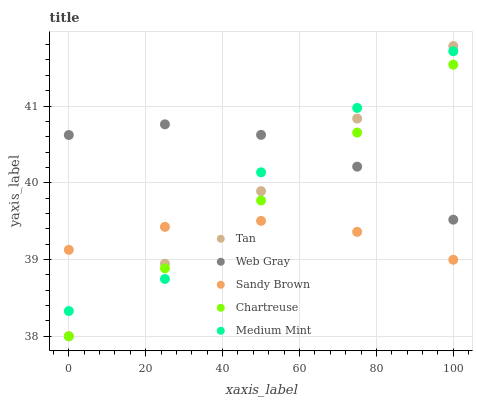Does Sandy Brown have the minimum area under the curve?
Answer yes or no. Yes. Does Web Gray have the maximum area under the curve?
Answer yes or no. Yes. Does Tan have the minimum area under the curve?
Answer yes or no. No. Does Tan have the maximum area under the curve?
Answer yes or no. No. Is Tan the smoothest?
Answer yes or no. Yes. Is Medium Mint the roughest?
Answer yes or no. Yes. Is Web Gray the smoothest?
Answer yes or no. No. Is Web Gray the roughest?
Answer yes or no. No. Does Tan have the lowest value?
Answer yes or no. Yes. Does Web Gray have the lowest value?
Answer yes or no. No. Does Tan have the highest value?
Answer yes or no. Yes. Does Web Gray have the highest value?
Answer yes or no. No. Is Sandy Brown less than Web Gray?
Answer yes or no. Yes. Is Web Gray greater than Sandy Brown?
Answer yes or no. Yes. Does Web Gray intersect Chartreuse?
Answer yes or no. Yes. Is Web Gray less than Chartreuse?
Answer yes or no. No. Is Web Gray greater than Chartreuse?
Answer yes or no. No. Does Sandy Brown intersect Web Gray?
Answer yes or no. No. 